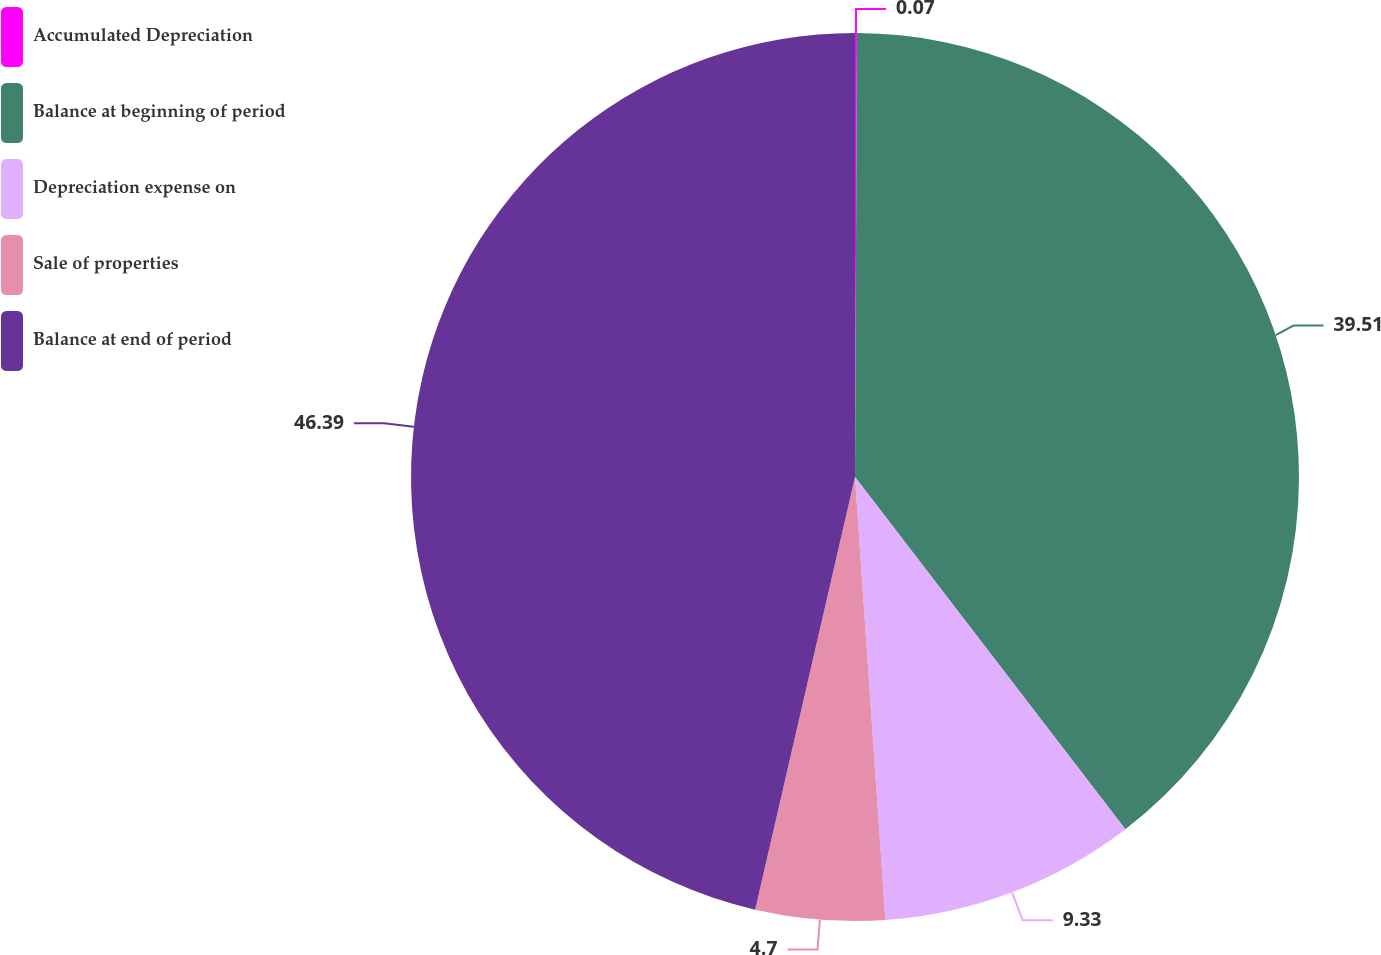Convert chart. <chart><loc_0><loc_0><loc_500><loc_500><pie_chart><fcel>Accumulated Depreciation<fcel>Balance at beginning of period<fcel>Depreciation expense on<fcel>Sale of properties<fcel>Balance at end of period<nl><fcel>0.07%<fcel>39.51%<fcel>9.33%<fcel>4.7%<fcel>46.39%<nl></chart> 